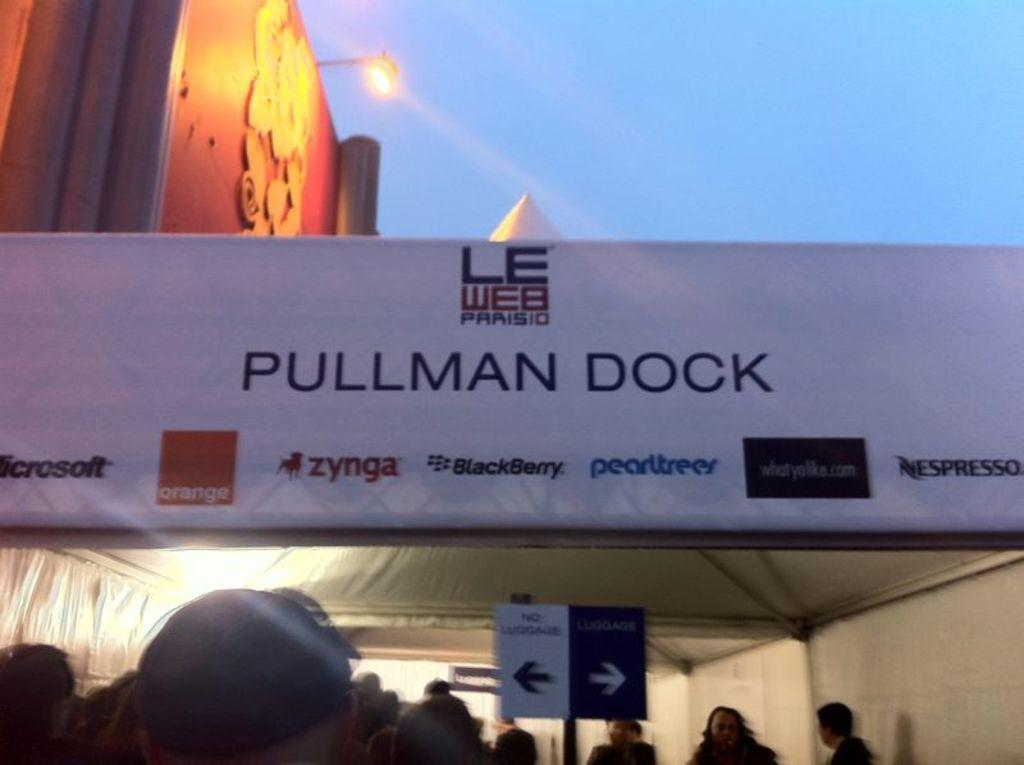<image>
Create a compact narrative representing the image presented. Many people are under a tent that states pullman dock for an event. 